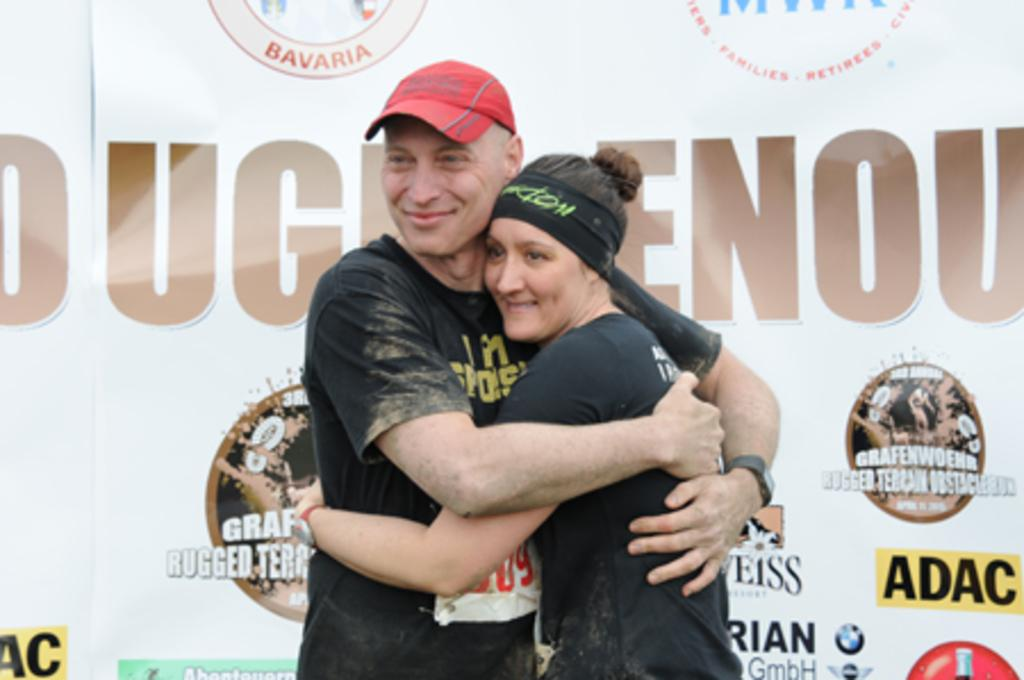Who are the people in the image? There is a man and a woman in the image. What are the man and woman doing in the image? The man and woman are hugging each other. What is the man wearing on his head? The man is wearing a red color hat. What can be seen in the background of the image? There is a poster in the background of the image. What type of sweater is the fireman wearing in the image? There is no fireman or sweater present in the image. Where is the park located in the image? There is no park present in the image. 